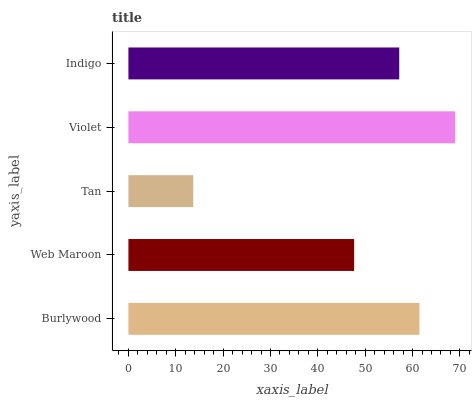Is Tan the minimum?
Answer yes or no. Yes. Is Violet the maximum?
Answer yes or no. Yes. Is Web Maroon the minimum?
Answer yes or no. No. Is Web Maroon the maximum?
Answer yes or no. No. Is Burlywood greater than Web Maroon?
Answer yes or no. Yes. Is Web Maroon less than Burlywood?
Answer yes or no. Yes. Is Web Maroon greater than Burlywood?
Answer yes or no. No. Is Burlywood less than Web Maroon?
Answer yes or no. No. Is Indigo the high median?
Answer yes or no. Yes. Is Indigo the low median?
Answer yes or no. Yes. Is Violet the high median?
Answer yes or no. No. Is Burlywood the low median?
Answer yes or no. No. 